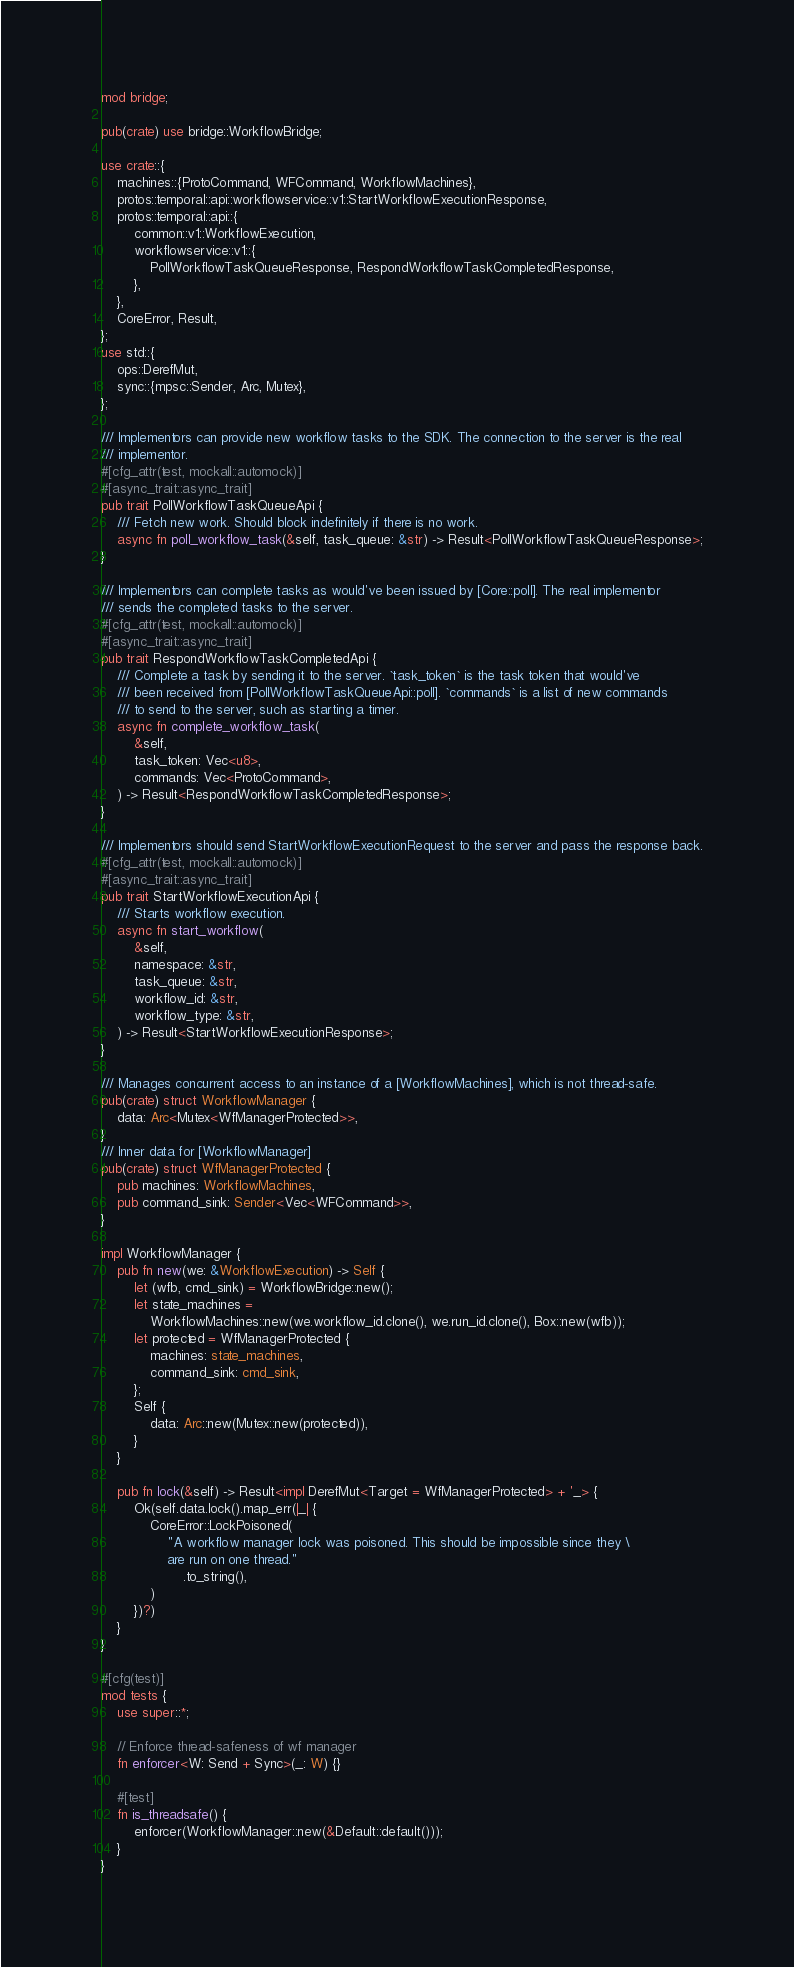<code> <loc_0><loc_0><loc_500><loc_500><_Rust_>mod bridge;

pub(crate) use bridge::WorkflowBridge;

use crate::{
    machines::{ProtoCommand, WFCommand, WorkflowMachines},
    protos::temporal::api::workflowservice::v1::StartWorkflowExecutionResponse,
    protos::temporal::api::{
        common::v1::WorkflowExecution,
        workflowservice::v1::{
            PollWorkflowTaskQueueResponse, RespondWorkflowTaskCompletedResponse,
        },
    },
    CoreError, Result,
};
use std::{
    ops::DerefMut,
    sync::{mpsc::Sender, Arc, Mutex},
};

/// Implementors can provide new workflow tasks to the SDK. The connection to the server is the real
/// implementor.
#[cfg_attr(test, mockall::automock)]
#[async_trait::async_trait]
pub trait PollWorkflowTaskQueueApi {
    /// Fetch new work. Should block indefinitely if there is no work.
    async fn poll_workflow_task(&self, task_queue: &str) -> Result<PollWorkflowTaskQueueResponse>;
}

/// Implementors can complete tasks as would've been issued by [Core::poll]. The real implementor
/// sends the completed tasks to the server.
#[cfg_attr(test, mockall::automock)]
#[async_trait::async_trait]
pub trait RespondWorkflowTaskCompletedApi {
    /// Complete a task by sending it to the server. `task_token` is the task token that would've
    /// been received from [PollWorkflowTaskQueueApi::poll]. `commands` is a list of new commands
    /// to send to the server, such as starting a timer.
    async fn complete_workflow_task(
        &self,
        task_token: Vec<u8>,
        commands: Vec<ProtoCommand>,
    ) -> Result<RespondWorkflowTaskCompletedResponse>;
}

/// Implementors should send StartWorkflowExecutionRequest to the server and pass the response back.
#[cfg_attr(test, mockall::automock)]
#[async_trait::async_trait]
pub trait StartWorkflowExecutionApi {
    /// Starts workflow execution.
    async fn start_workflow(
        &self,
        namespace: &str,
        task_queue: &str,
        workflow_id: &str,
        workflow_type: &str,
    ) -> Result<StartWorkflowExecutionResponse>;
}

/// Manages concurrent access to an instance of a [WorkflowMachines], which is not thread-safe.
pub(crate) struct WorkflowManager {
    data: Arc<Mutex<WfManagerProtected>>,
}
/// Inner data for [WorkflowManager]
pub(crate) struct WfManagerProtected {
    pub machines: WorkflowMachines,
    pub command_sink: Sender<Vec<WFCommand>>,
}

impl WorkflowManager {
    pub fn new(we: &WorkflowExecution) -> Self {
        let (wfb, cmd_sink) = WorkflowBridge::new();
        let state_machines =
            WorkflowMachines::new(we.workflow_id.clone(), we.run_id.clone(), Box::new(wfb));
        let protected = WfManagerProtected {
            machines: state_machines,
            command_sink: cmd_sink,
        };
        Self {
            data: Arc::new(Mutex::new(protected)),
        }
    }

    pub fn lock(&self) -> Result<impl DerefMut<Target = WfManagerProtected> + '_> {
        Ok(self.data.lock().map_err(|_| {
            CoreError::LockPoisoned(
                "A workflow manager lock was poisoned. This should be impossible since they \
                are run on one thread."
                    .to_string(),
            )
        })?)
    }
}

#[cfg(test)]
mod tests {
    use super::*;

    // Enforce thread-safeness of wf manager
    fn enforcer<W: Send + Sync>(_: W) {}

    #[test]
    fn is_threadsafe() {
        enforcer(WorkflowManager::new(&Default::default()));
    }
}
</code> 